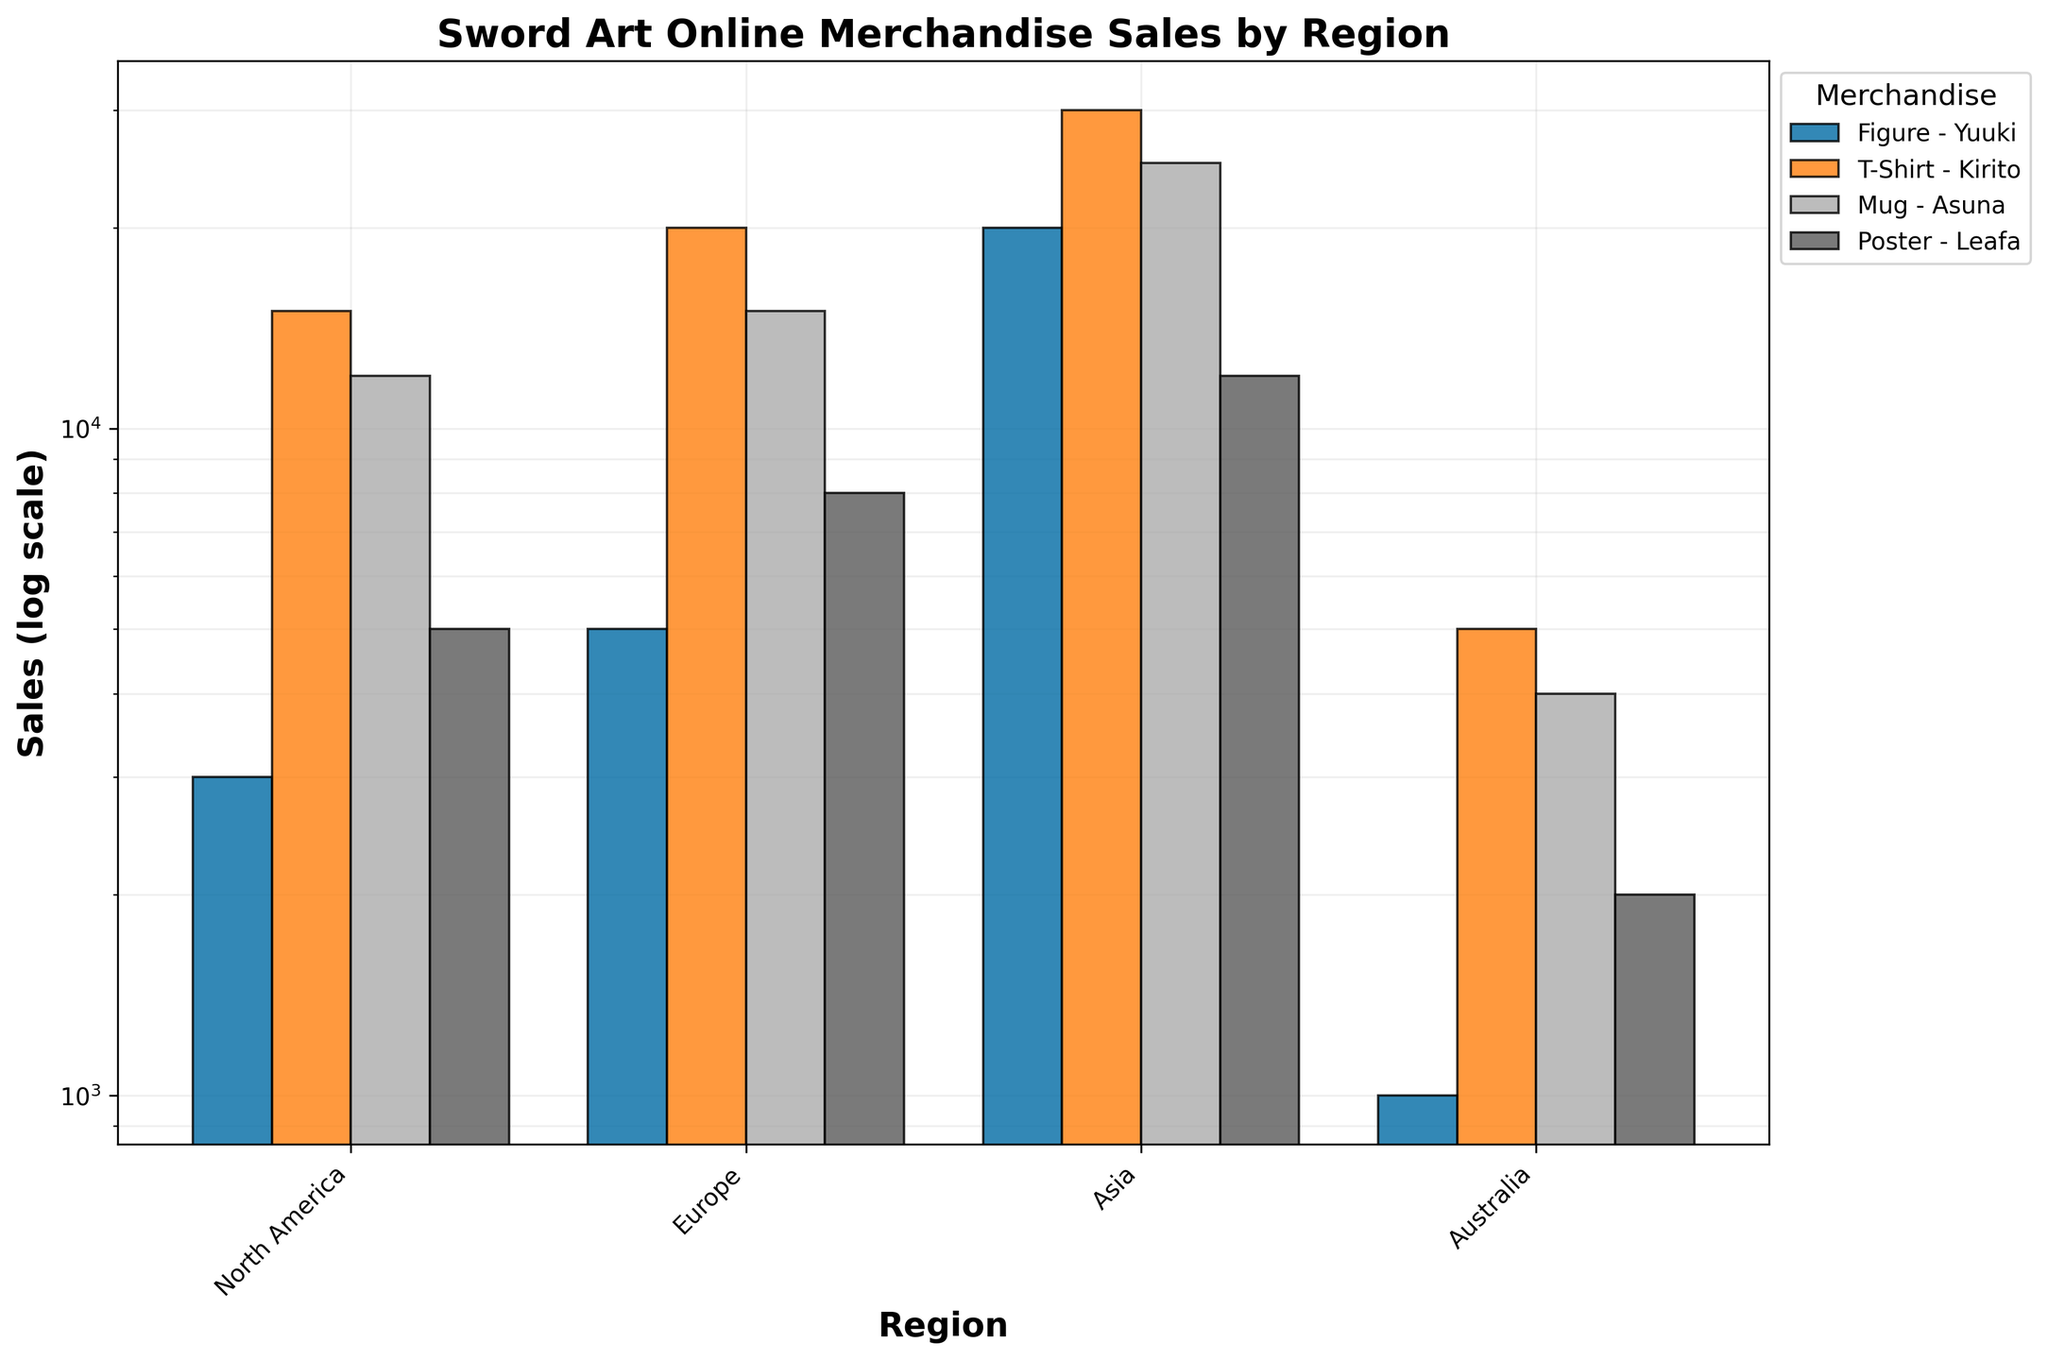what is the title of the figure? The title of the figure is prominently displayed at the top and reads "Sword Art Online Merchandise Sales by Region."
Answer: Sword Art Online Merchandise Sales by Region Which region has the highest sales for "Figure - Yuuki"? By looking at the height of the bars for "Figure - Yuuki" in different regions, the bar for Asia is the tallest, indicating the highest sales.
Answer: Asia What is the combined sales number of "Poster - Leafa" in North America and Europe? The sales for "Poster - Leafa" in North America is 5000, and in Europe, it is 8000. Adding these values together gives 5000 + 8000 = 13000.
Answer: 13000 How do sales of "T-Shirt - Kirito" in North America compare to sales in Australia? The bar for "T-Shirt - Kirito" in North America is higher than the one in Australia. Specifically, the sales in North America are 15000 compared to 5000 in Australia.
Answer: 15000 > 5000 What’s the average sales for "Mug - Asuna" across all regions? The sales figures for "Mug - Asuna" are as follows: NA - 12000, Europe - 15000, Asia - 25000, Australia - 4000. Adding these together: 12000 + 15000 + 25000 + 4000 = 56000. There are 4 regions, so the average is 56000 / 4 = 14000.
Answer: 14000 Which merchandise item has the least sales in Asia? By comparing the heights of the bars for each merchandise in the Asia region, "Poster - Leafa" has the shortest bar.
Answer: Poster - Leafa What is the ratio of sales for "Figure - Yuuki" in Asia to Australia? The sales in Asia for "Figure - Yuuki" is 20000 and in Australia is 1000. The ratio is 20000 / 1000 = 20.
Answer: 20 Across which regions is "T-Shirt - Kirito" the most popular in terms of sales? "T-Shirt - Kirito" has the highest sales in Asia, as reflected by the tallest bar in the corresponding region.
Answer: Asia What is the difference in sales between "Mug - Asuna" in Europe and North America? The sales in Europe for "Mug - Asuna" is 15000 and in North America is 12000. The difference is 15000 - 12000 = 3000.
Answer: 3000 On a log scale, which item shows the most significant variance in sales across regions? By observing the heights of the different bars for all items, "T-Shirt - Kirito" exhibits the most significant variance, as it shows extreme differences in sales across regions.
Answer: T-Shirt - Kirito 